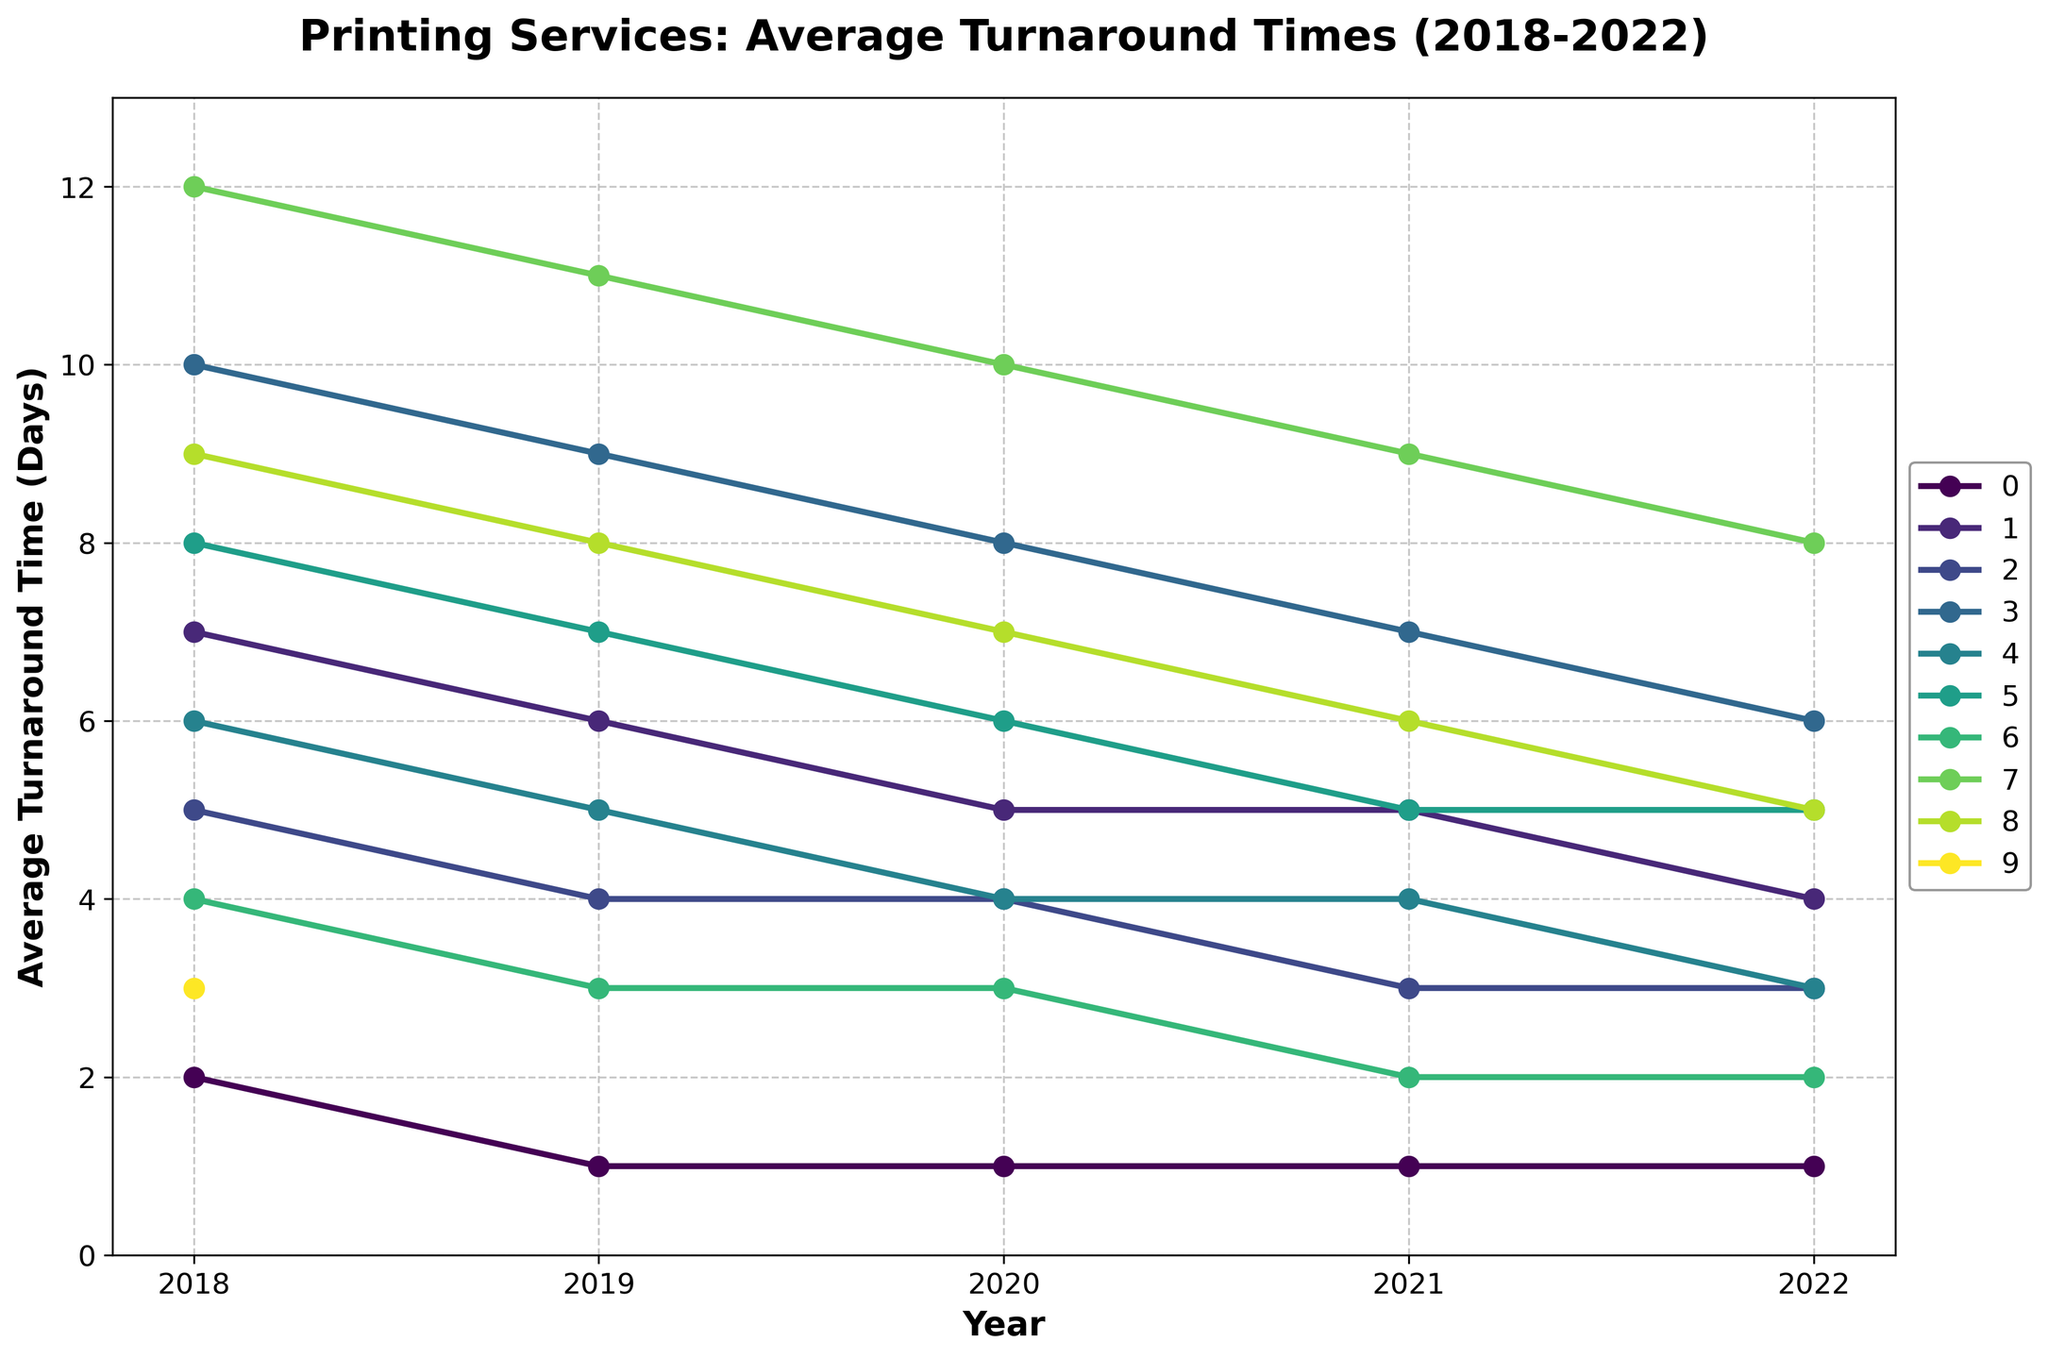What's the range of turnaround times for Trafford Publishing from 2018 to 2022? The minimum turnaround time for Trafford Publishing is 8 days in 2022, and the maximum is 12 days in 2018. The range is calculated as 12 - 8.
Answer: 4 Between Amazon KDP and IngramSpark, which service had a larger decrease in turnaround time from 2018 to 2022? Amazon KDP decreased from 2 days in 2018 to 1 day in 2022, which is a decrease of 1 day. IngramSpark decreased from 7 days in 2018 to 4 days in 2022, which is a decrease of 3 days.
Answer: IngramSpark Which printing service had the most consistent (least variable) turnaround time from 2018 to 2022? Amazon KDP consistently had a turnaround time of 1 day from 2019 to 2022, showing the least variability.
Answer: Amazon KDP How many services had a turnaround time of 5 days or more in 2022? In 2022, the services with turnaround times of 5 days or more are IngramSpark (4 days), BookBaby (6 days), Xlibris (5 days), and Trafford Publishing (8 days). This gives us a total of 4 services.
Answer: 4 Which service showed the greatest overall improvement (decrease in turnaround time) from 2018 to 2022? Trafford Publishing's turnaround time decreased from 12 days in 2018 to 8 days in 2022, which is an improvement of 4 days. Other services had less than a 4-day improvement or started with fewer than 12 days.
Answer: Trafford Publishing Between BookBaby and Blurb, which service had the higher turnaround time in 2019? In 2019, BookBaby had a turnaround time of 9 days, while Blurb had 5 days.
Answer: BookBaby What was the average turnaround time of all services in 2021? Summing all the turnaround times in 2021: Amazon KDP (1), IngramSpark (5), Lulu (3), BookBaby (7), Blurb (4), Lightning Source (5), Barnes & Noble Press (2), Trafford Publishing (9), Xlibris (6). The total is 42 days. There are 9 services, so the average is 42 / 9.
Answer: 4.67 Visualize which service lines have the steepest decline between any two consecutive years. The steepest decline between consecutive years appears to be for Trafford Publishing from 2018 to 2019, where the line sharply descends.
Answer: Trafford Publishing 